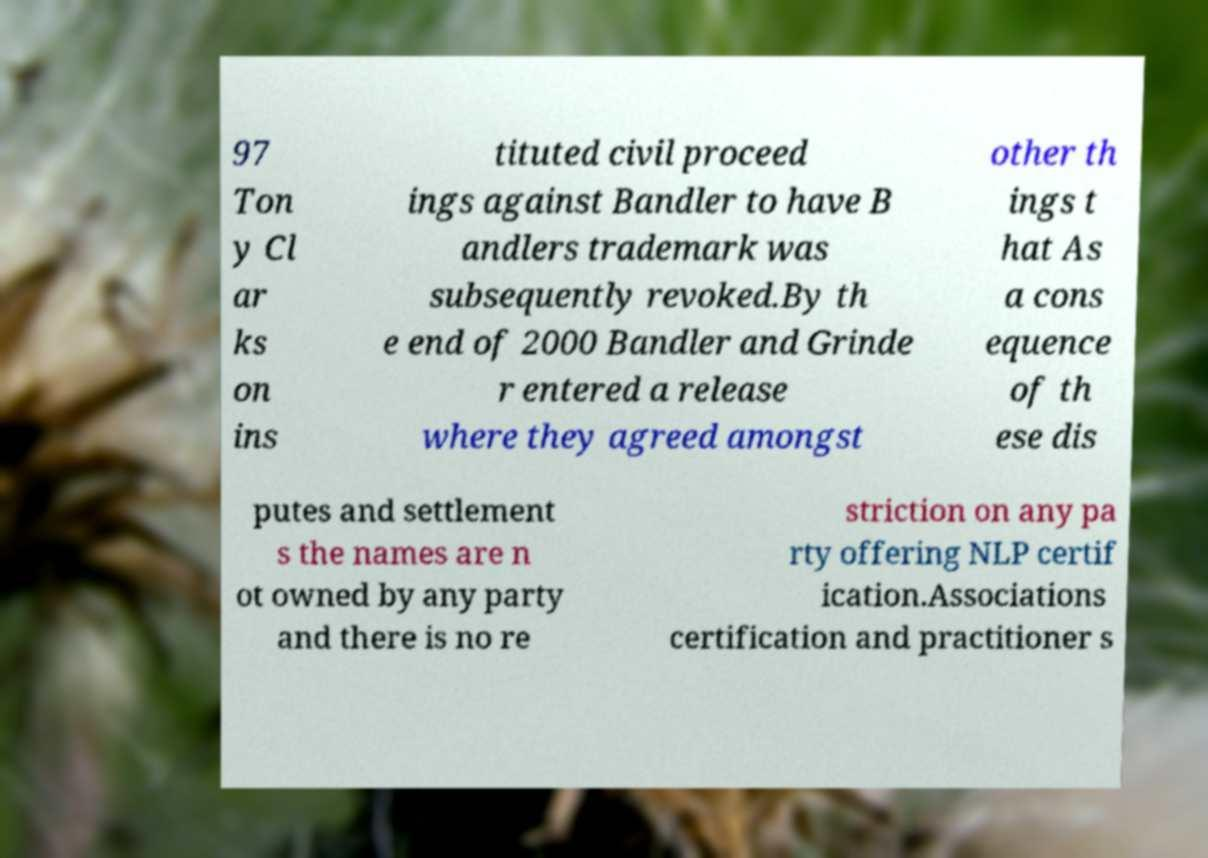What messages or text are displayed in this image? I need them in a readable, typed format. 97 Ton y Cl ar ks on ins tituted civil proceed ings against Bandler to have B andlers trademark was subsequently revoked.By th e end of 2000 Bandler and Grinde r entered a release where they agreed amongst other th ings t hat As a cons equence of th ese dis putes and settlement s the names are n ot owned by any party and there is no re striction on any pa rty offering NLP certif ication.Associations certification and practitioner s 